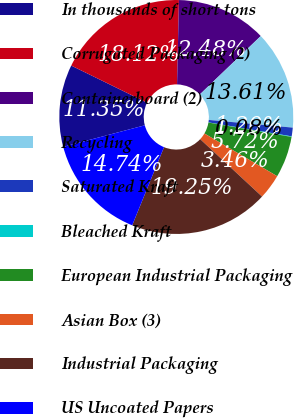<chart> <loc_0><loc_0><loc_500><loc_500><pie_chart><fcel>In thousands of short tons<fcel>Corrugated Packaging (2)<fcel>Containerboard (2)<fcel>Recycling<fcel>Saturated Kraft<fcel>Bleached Kraft<fcel>European Industrial Packaging<fcel>Asian Box (3)<fcel>Industrial Packaging<fcel>US Uncoated Papers<nl><fcel>11.35%<fcel>18.12%<fcel>12.48%<fcel>13.61%<fcel>1.2%<fcel>0.08%<fcel>5.72%<fcel>3.46%<fcel>19.25%<fcel>14.74%<nl></chart> 